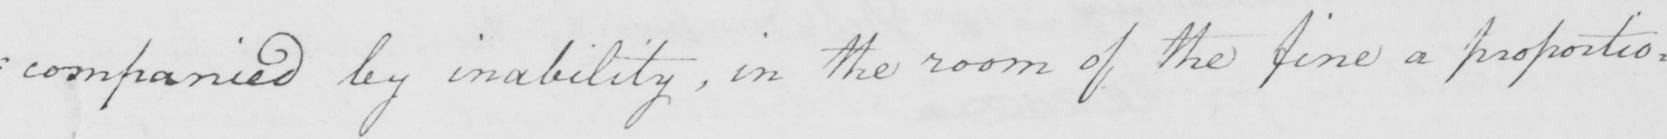What text is written in this handwritten line? : companied by inability , in the room of the fine a proportio= 